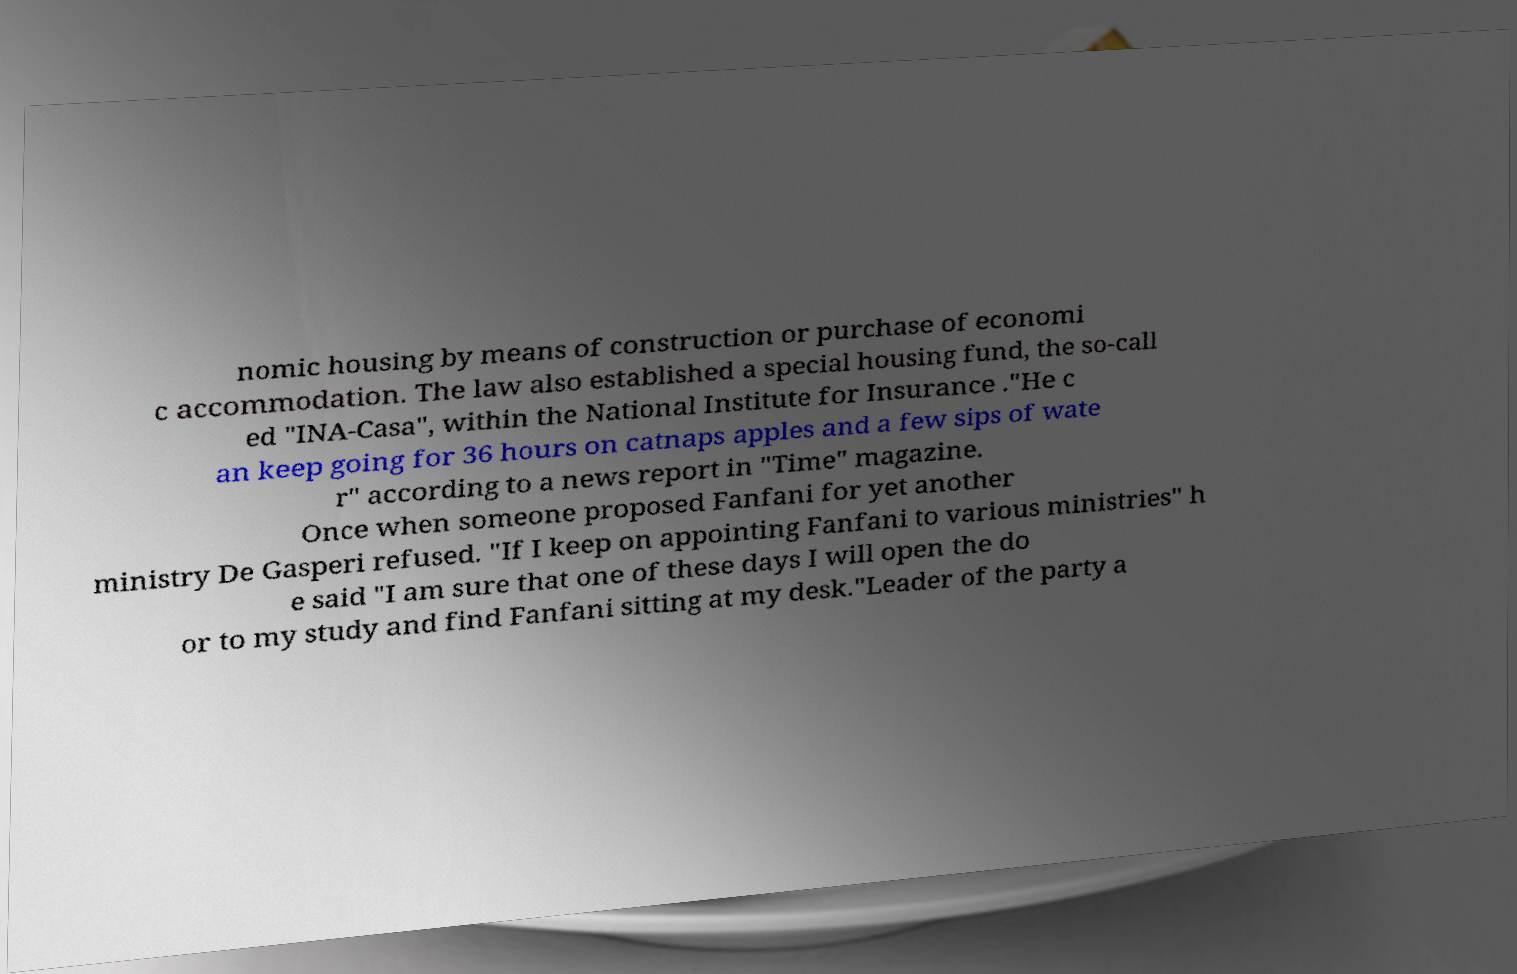I need the written content from this picture converted into text. Can you do that? nomic housing by means of construction or purchase of economi c accommodation. The law also established a special housing fund, the so-call ed "INA-Casa", within the National Institute for Insurance ."He c an keep going for 36 hours on catnaps apples and a few sips of wate r" according to a news report in "Time" magazine. Once when someone proposed Fanfani for yet another ministry De Gasperi refused. "If I keep on appointing Fanfani to various ministries" h e said "I am sure that one of these days I will open the do or to my study and find Fanfani sitting at my desk."Leader of the party a 